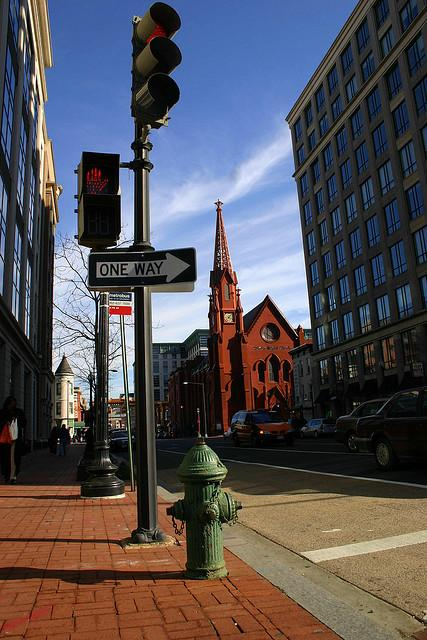Which way can those cars turn? right 